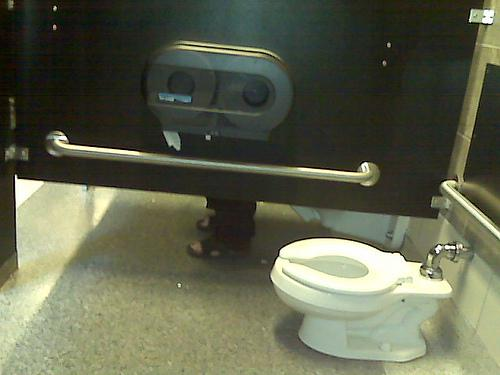Question: what kind of shoes is the person wearing?
Choices:
A. High heels.
B. Sandals.
C. Sneakers.
D. Flats.
Answer with the letter. Answer: B Question: how many rolls of toilet paper are there?
Choices:
A. 3.
B. 4.
C. 5.
D. 2.
Answer with the letter. Answer: D 